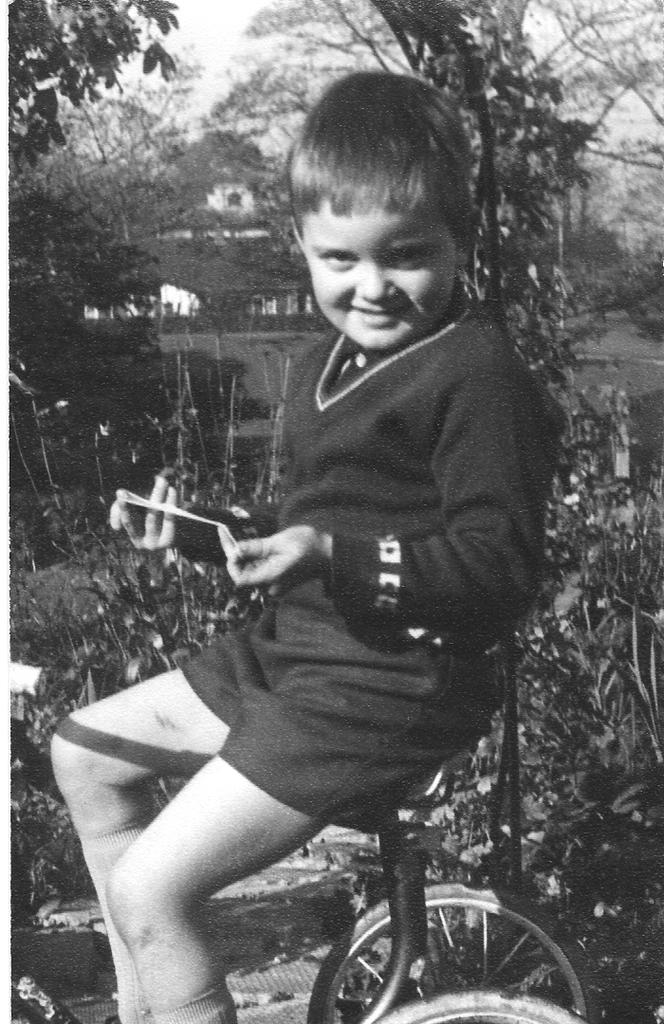What is the main subject of the image? The main subject of the image is a kid. What is the kid doing in the image? The kid is sitting on a bicycle. What type of background can be seen in the image? There are trees in the image. What is the color scheme of the image? The image is black and white. How many eyes can be seen on the kid's face in the image? The image is black and white, and it is not possible to determine the number of eyes on the kid's face from the provided information. 